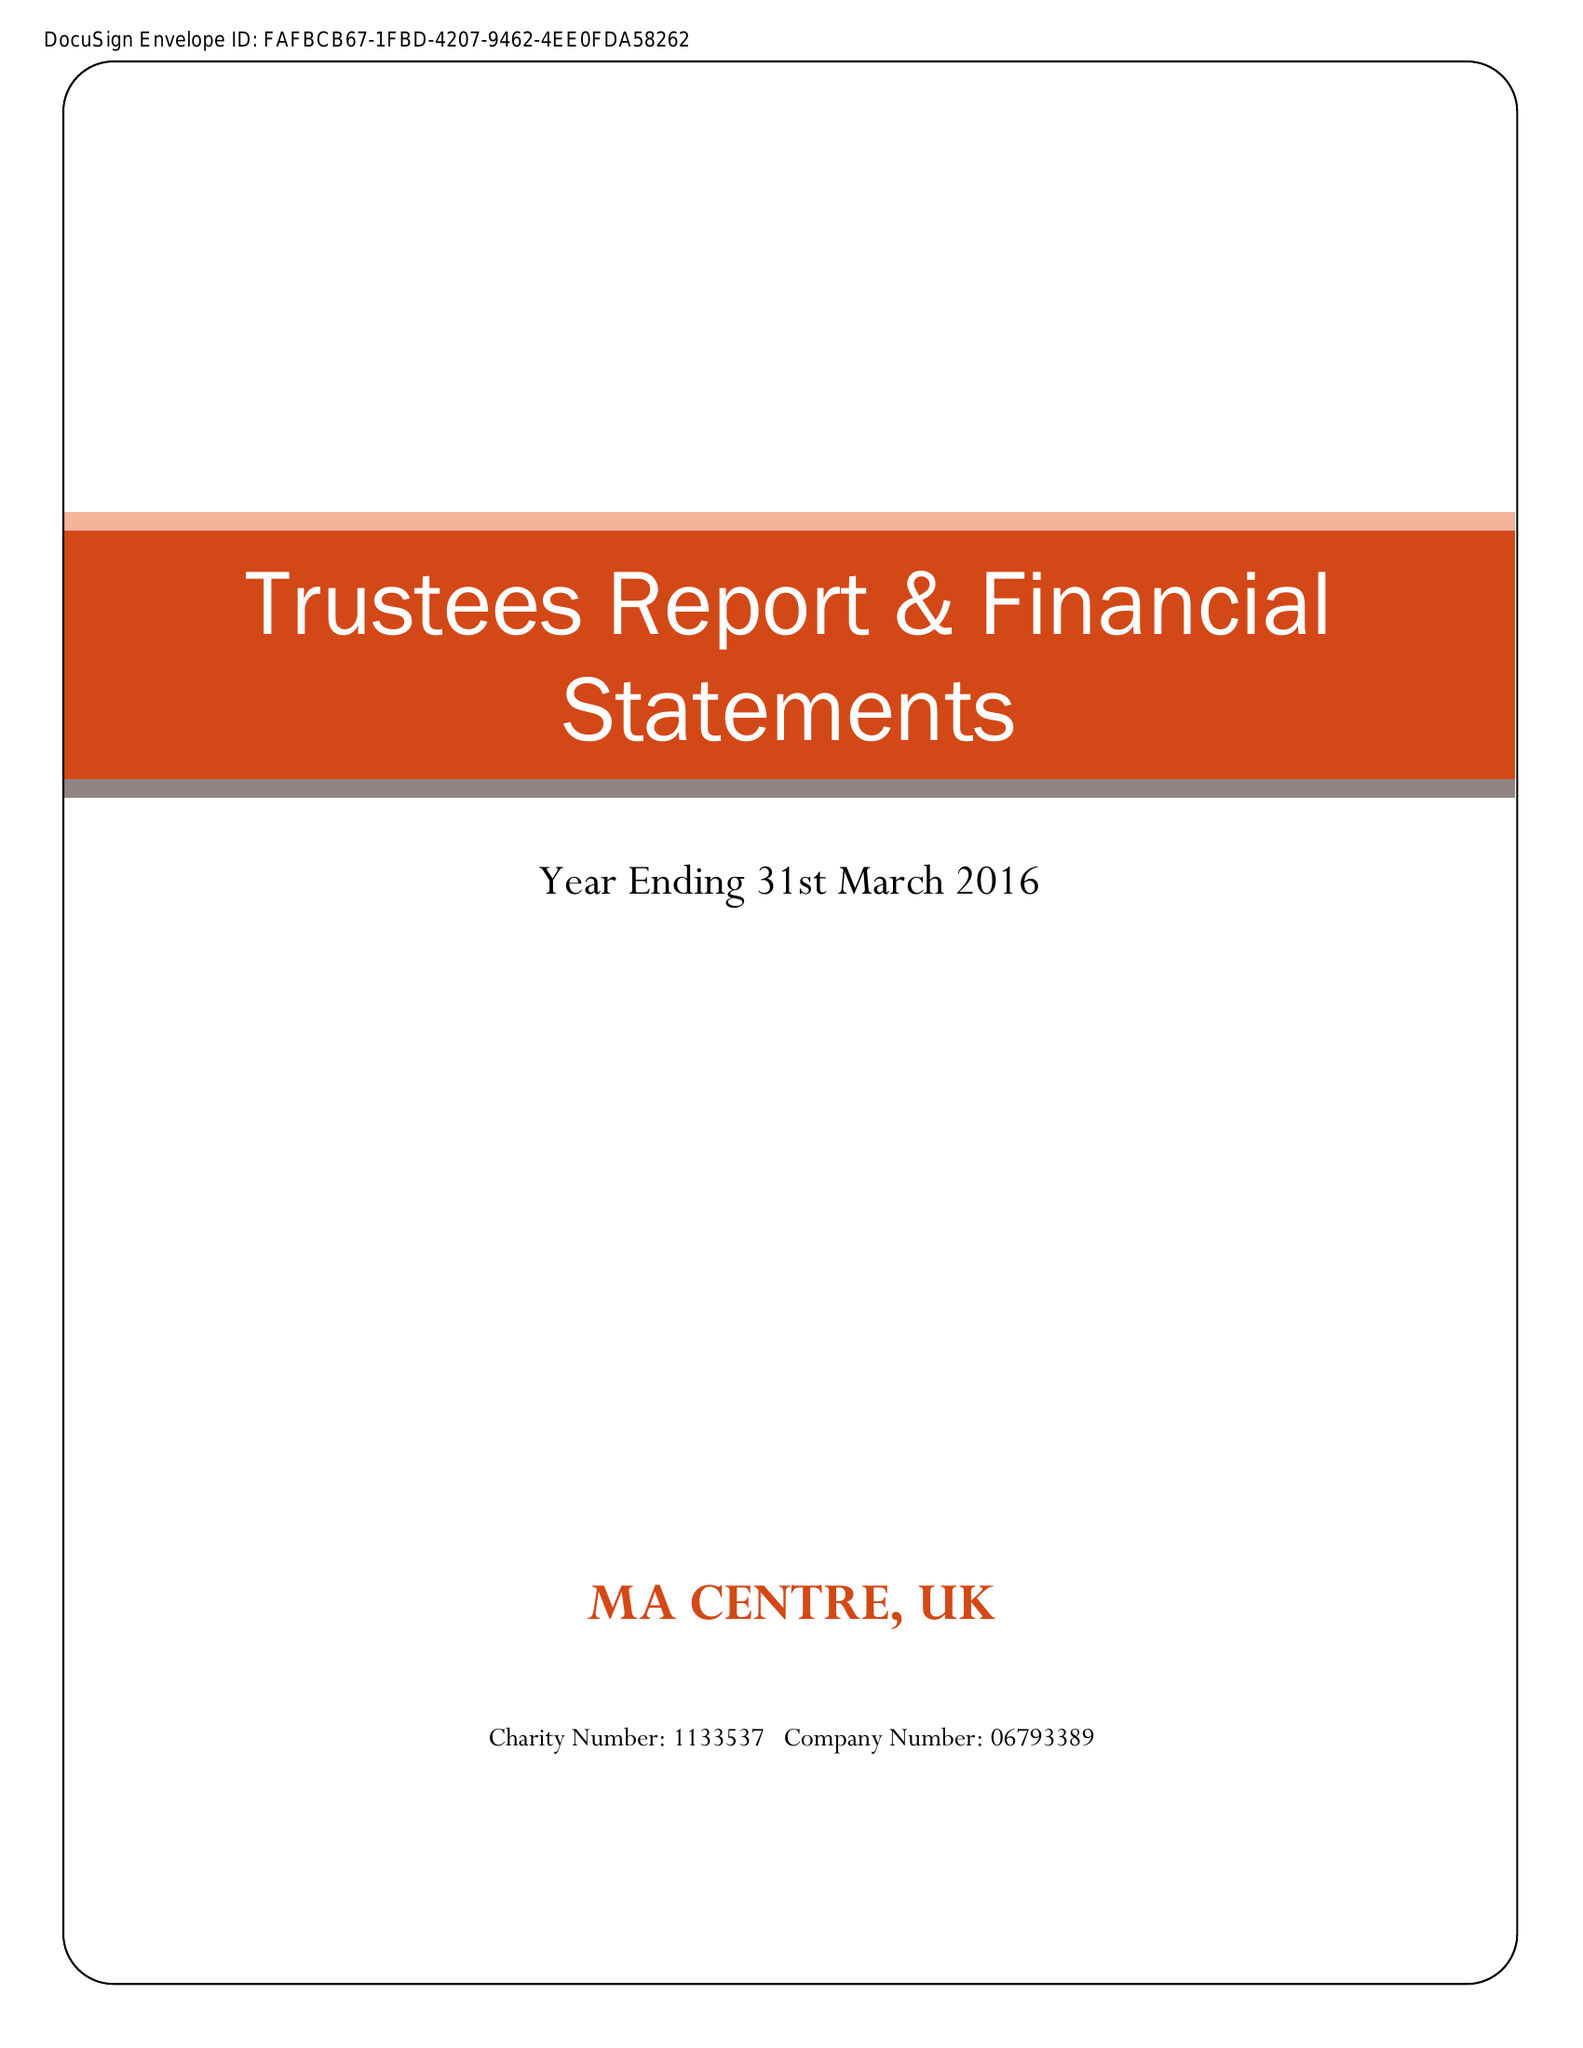What is the value for the address__post_town?
Answer the question using a single word or phrase. BROMLEY 